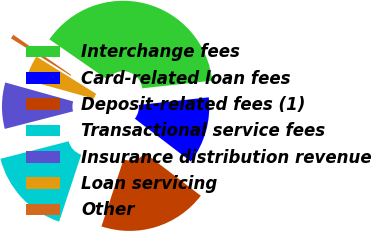Convert chart. <chart><loc_0><loc_0><loc_500><loc_500><pie_chart><fcel>Interchange fees<fcel>Card-related loan fees<fcel>Deposit-related fees (1)<fcel>Transactional service fees<fcel>Insurance distribution revenue<fcel>Loan servicing<fcel>Other<nl><fcel>38.62%<fcel>12.12%<fcel>19.69%<fcel>15.91%<fcel>8.34%<fcel>4.55%<fcel>0.76%<nl></chart> 